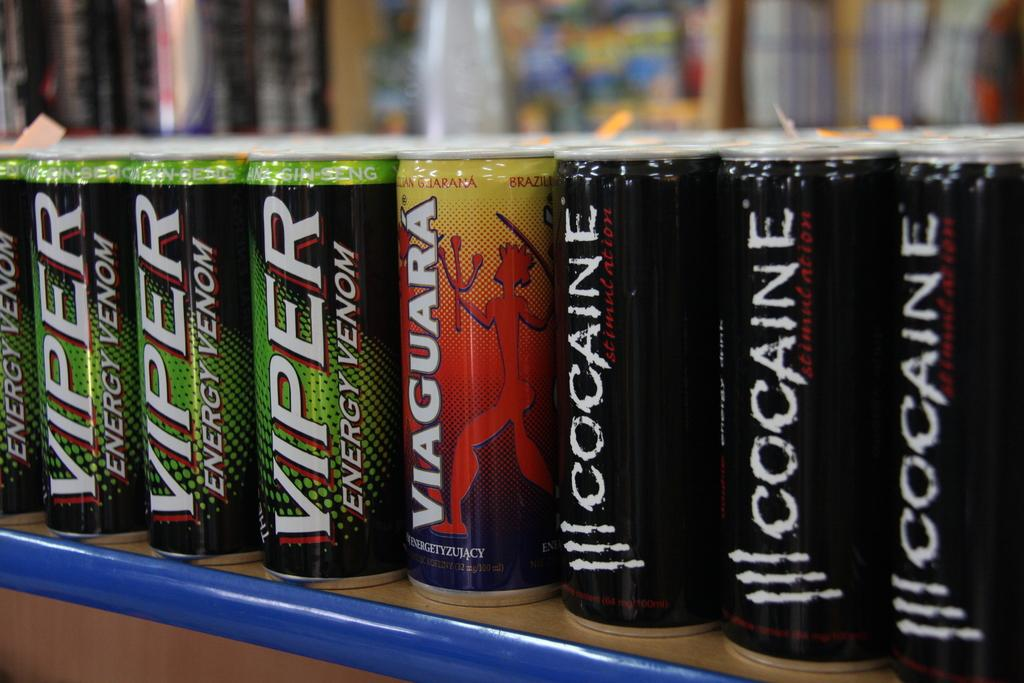<image>
Relay a brief, clear account of the picture shown. Several cans of Viper energy venom sit on a shelf with other energy drinks. 